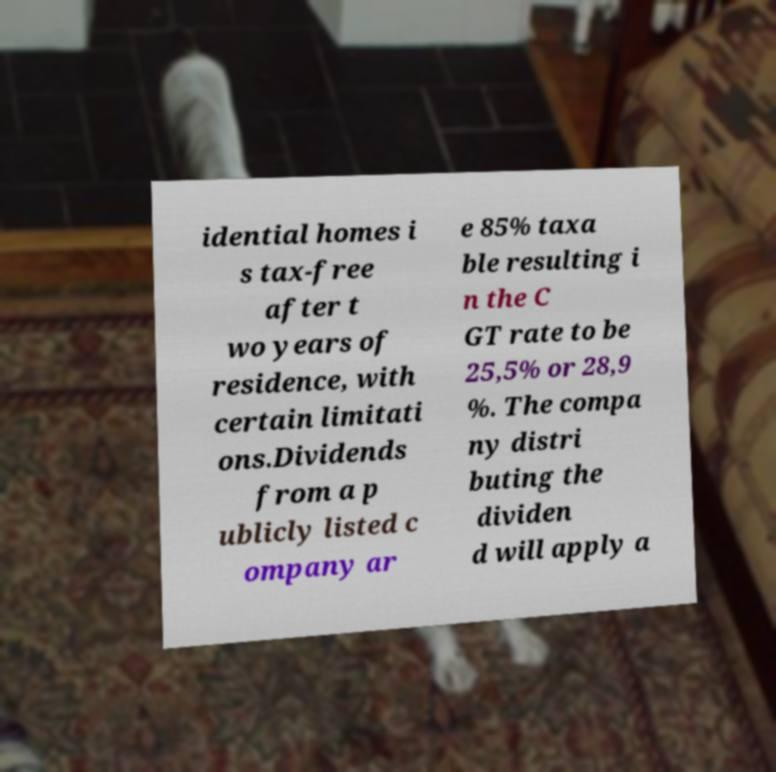What messages or text are displayed in this image? I need them in a readable, typed format. idential homes i s tax-free after t wo years of residence, with certain limitati ons.Dividends from a p ublicly listed c ompany ar e 85% taxa ble resulting i n the C GT rate to be 25,5% or 28,9 %. The compa ny distri buting the dividen d will apply a 